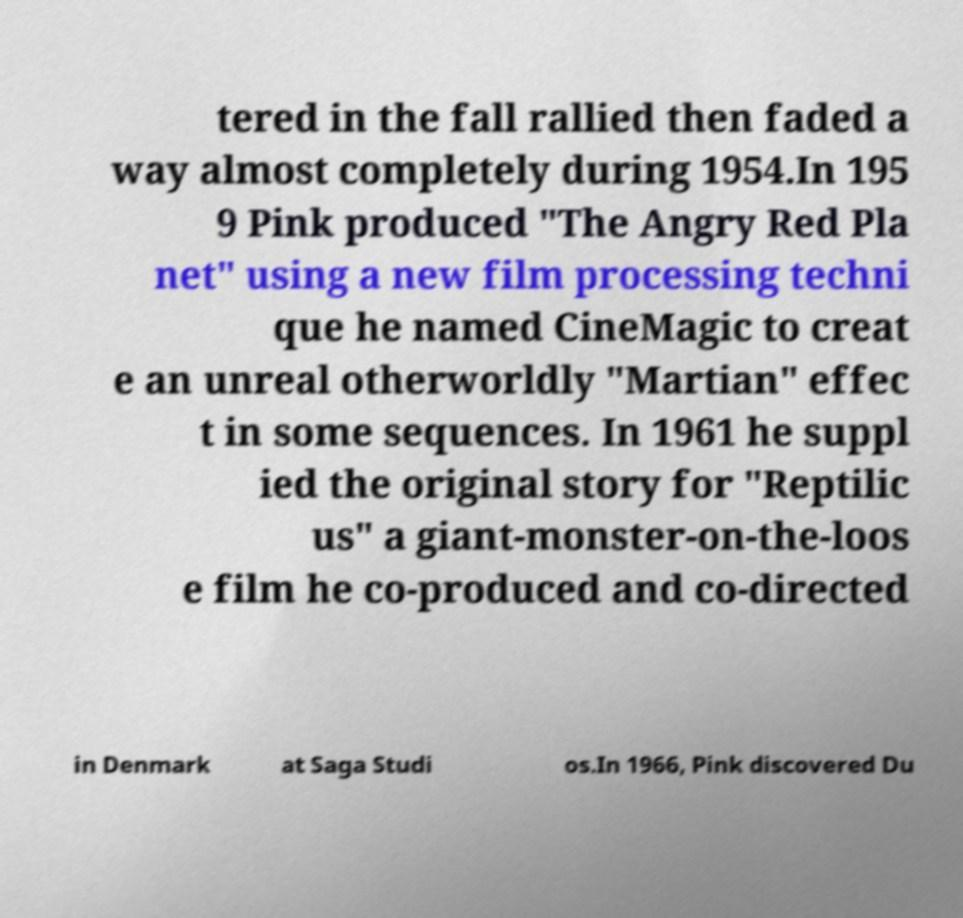Please read and relay the text visible in this image. What does it say? tered in the fall rallied then faded a way almost completely during 1954.In 195 9 Pink produced "The Angry Red Pla net" using a new film processing techni que he named CineMagic to creat e an unreal otherworldly "Martian" effec t in some sequences. In 1961 he suppl ied the original story for "Reptilic us" a giant-monster-on-the-loos e film he co-produced and co-directed in Denmark at Saga Studi os.In 1966, Pink discovered Du 